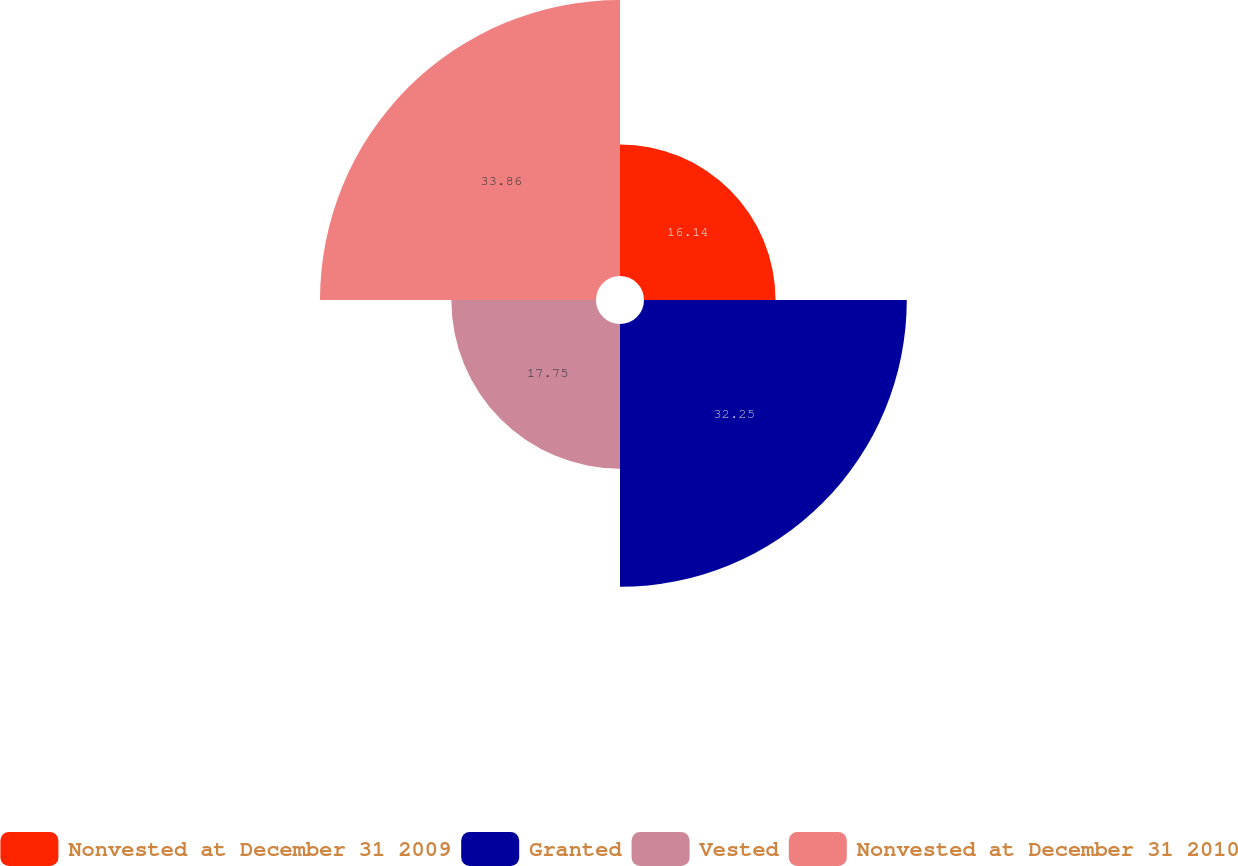Convert chart. <chart><loc_0><loc_0><loc_500><loc_500><pie_chart><fcel>Nonvested at December 31 2009<fcel>Granted<fcel>Vested<fcel>Nonvested at December 31 2010<nl><fcel>16.14%<fcel>32.25%<fcel>17.75%<fcel>33.87%<nl></chart> 